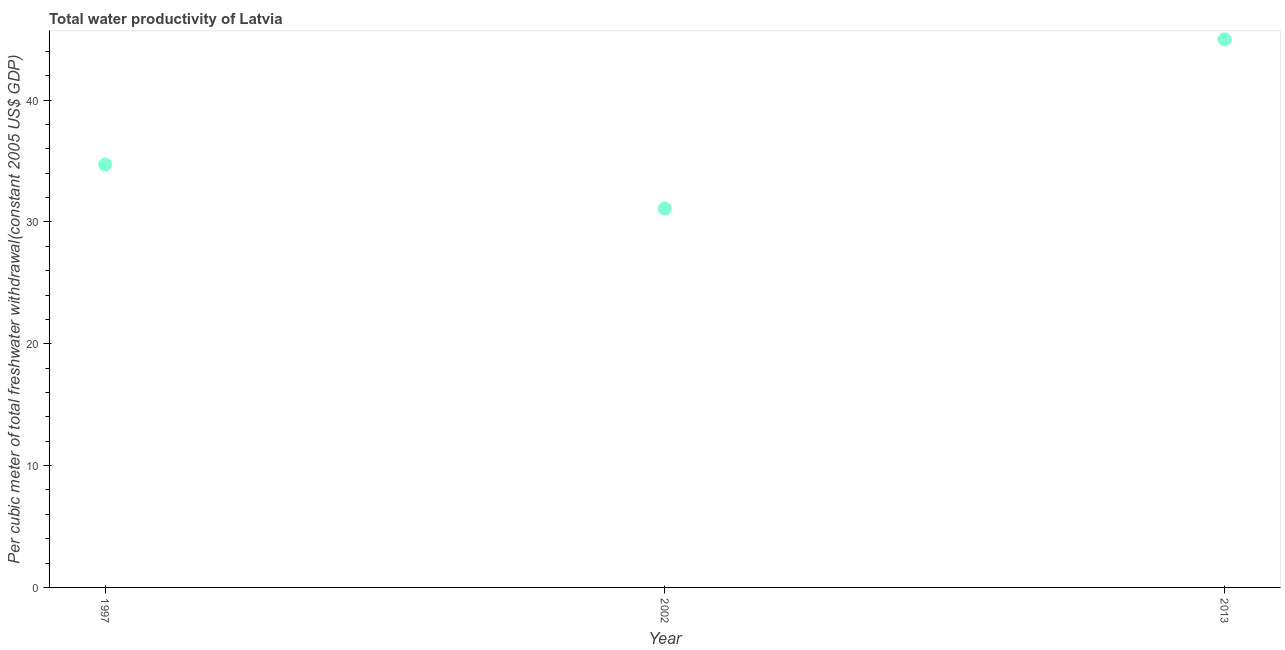What is the total water productivity in 1997?
Your answer should be very brief. 34.71. Across all years, what is the maximum total water productivity?
Keep it short and to the point. 44.99. Across all years, what is the minimum total water productivity?
Offer a very short reply. 31.1. What is the sum of the total water productivity?
Your response must be concise. 110.8. What is the difference between the total water productivity in 1997 and 2002?
Ensure brevity in your answer.  3.61. What is the average total water productivity per year?
Your response must be concise. 36.93. What is the median total water productivity?
Your response must be concise. 34.71. In how many years, is the total water productivity greater than 12 US$?
Your response must be concise. 3. Do a majority of the years between 2013 and 2002 (inclusive) have total water productivity greater than 24 US$?
Offer a very short reply. No. What is the ratio of the total water productivity in 1997 to that in 2013?
Offer a terse response. 0.77. Is the total water productivity in 1997 less than that in 2002?
Offer a terse response. No. What is the difference between the highest and the second highest total water productivity?
Your answer should be very brief. 10.28. Is the sum of the total water productivity in 1997 and 2002 greater than the maximum total water productivity across all years?
Provide a short and direct response. Yes. What is the difference between the highest and the lowest total water productivity?
Provide a succinct answer. 13.89. In how many years, is the total water productivity greater than the average total water productivity taken over all years?
Ensure brevity in your answer.  1. Does the total water productivity monotonically increase over the years?
Provide a short and direct response. No. Are the values on the major ticks of Y-axis written in scientific E-notation?
Your response must be concise. No. Does the graph contain any zero values?
Keep it short and to the point. No. What is the title of the graph?
Make the answer very short. Total water productivity of Latvia. What is the label or title of the Y-axis?
Offer a very short reply. Per cubic meter of total freshwater withdrawal(constant 2005 US$ GDP). What is the Per cubic meter of total freshwater withdrawal(constant 2005 US$ GDP) in 1997?
Give a very brief answer. 34.71. What is the Per cubic meter of total freshwater withdrawal(constant 2005 US$ GDP) in 2002?
Provide a short and direct response. 31.1. What is the Per cubic meter of total freshwater withdrawal(constant 2005 US$ GDP) in 2013?
Provide a succinct answer. 44.99. What is the difference between the Per cubic meter of total freshwater withdrawal(constant 2005 US$ GDP) in 1997 and 2002?
Ensure brevity in your answer.  3.61. What is the difference between the Per cubic meter of total freshwater withdrawal(constant 2005 US$ GDP) in 1997 and 2013?
Your answer should be compact. -10.28. What is the difference between the Per cubic meter of total freshwater withdrawal(constant 2005 US$ GDP) in 2002 and 2013?
Your response must be concise. -13.89. What is the ratio of the Per cubic meter of total freshwater withdrawal(constant 2005 US$ GDP) in 1997 to that in 2002?
Keep it short and to the point. 1.12. What is the ratio of the Per cubic meter of total freshwater withdrawal(constant 2005 US$ GDP) in 1997 to that in 2013?
Ensure brevity in your answer.  0.77. What is the ratio of the Per cubic meter of total freshwater withdrawal(constant 2005 US$ GDP) in 2002 to that in 2013?
Ensure brevity in your answer.  0.69. 